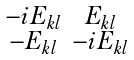<formula> <loc_0><loc_0><loc_500><loc_500>\begin{smallmatrix} - i E _ { k l } & E _ { k l } \\ - E _ { k l } & - i E _ { k l } \end{smallmatrix}</formula> 